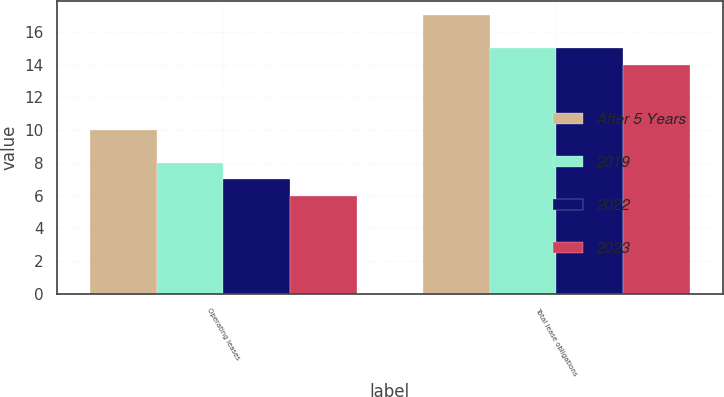Convert chart to OTSL. <chart><loc_0><loc_0><loc_500><loc_500><stacked_bar_chart><ecel><fcel>Operating leases<fcel>Total lease obligations<nl><fcel>After 5 Years<fcel>10<fcel>17<nl><fcel>2019<fcel>8<fcel>15<nl><fcel>2022<fcel>7<fcel>15<nl><fcel>2023<fcel>6<fcel>14<nl></chart> 